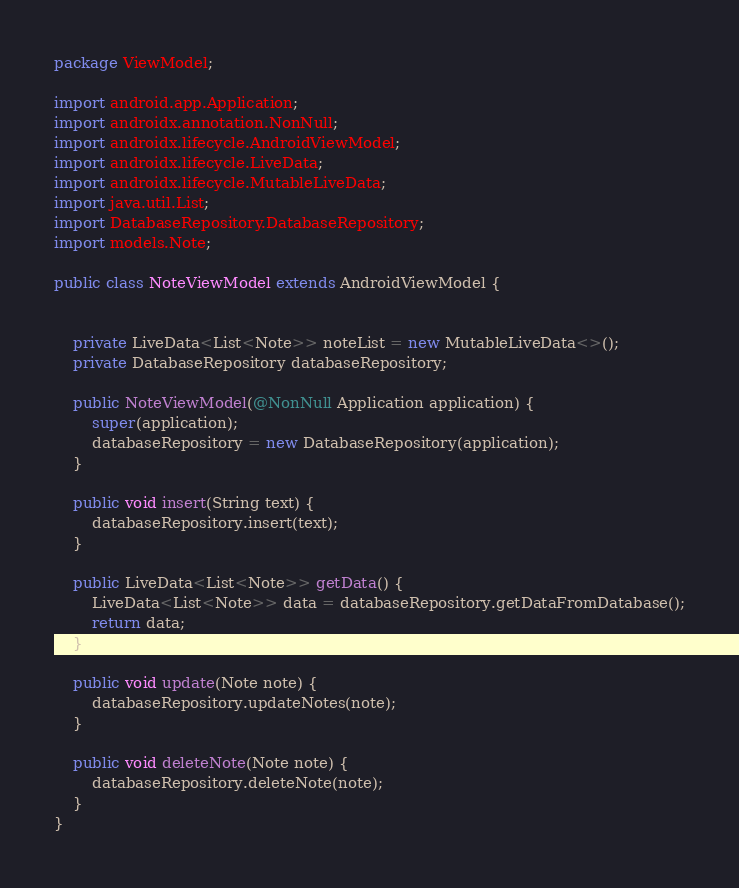Convert code to text. <code><loc_0><loc_0><loc_500><loc_500><_Java_>package ViewModel;

import android.app.Application;
import androidx.annotation.NonNull;
import androidx.lifecycle.AndroidViewModel;
import androidx.lifecycle.LiveData;
import androidx.lifecycle.MutableLiveData;
import java.util.List;
import DatabaseRepository.DatabaseRepository;
import models.Note;

public class NoteViewModel extends AndroidViewModel {


    private LiveData<List<Note>> noteList = new MutableLiveData<>();
    private DatabaseRepository databaseRepository;

    public NoteViewModel(@NonNull Application application) {
        super(application);
        databaseRepository = new DatabaseRepository(application);
    }

    public void insert(String text) {
        databaseRepository.insert(text);
    }

    public LiveData<List<Note>> getData() {
        LiveData<List<Note>> data = databaseRepository.getDataFromDatabase();
        return data;
    }

    public void update(Note note) {
        databaseRepository.updateNotes(note);
    }

    public void deleteNote(Note note) {
        databaseRepository.deleteNote(note);
    }
}
</code> 